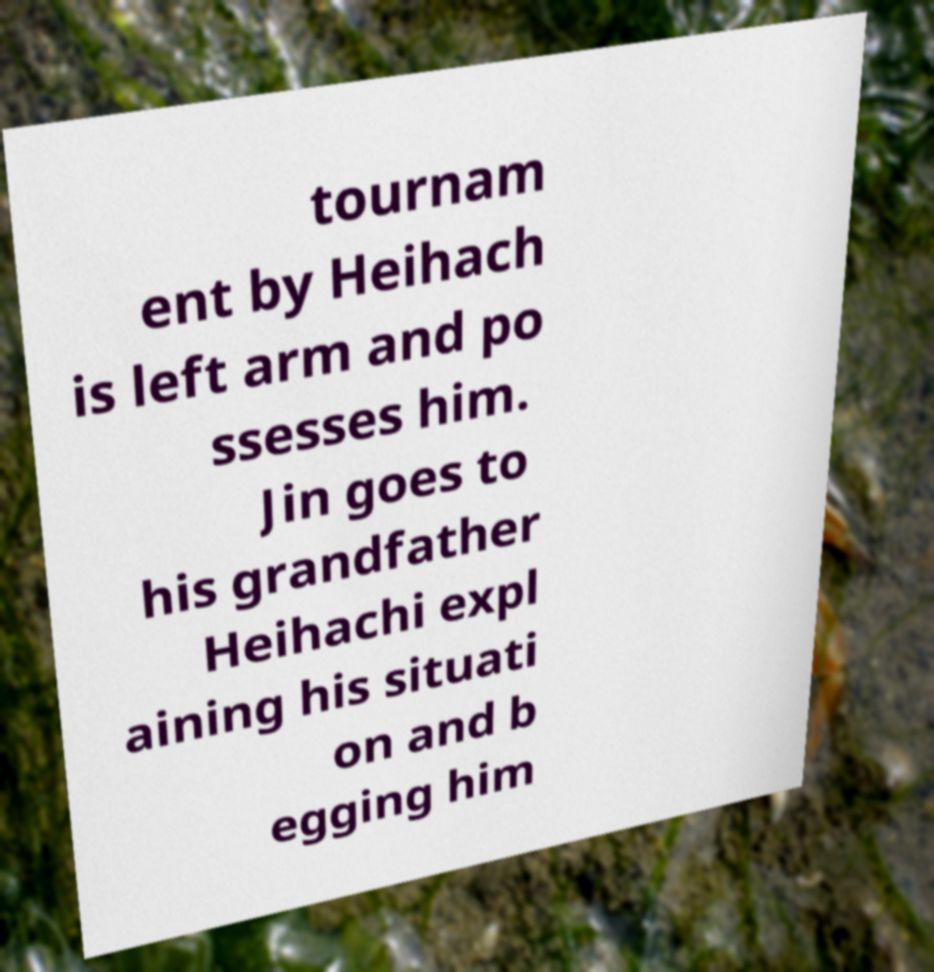Can you accurately transcribe the text from the provided image for me? tournam ent by Heihach is left arm and po ssesses him. Jin goes to his grandfather Heihachi expl aining his situati on and b egging him 